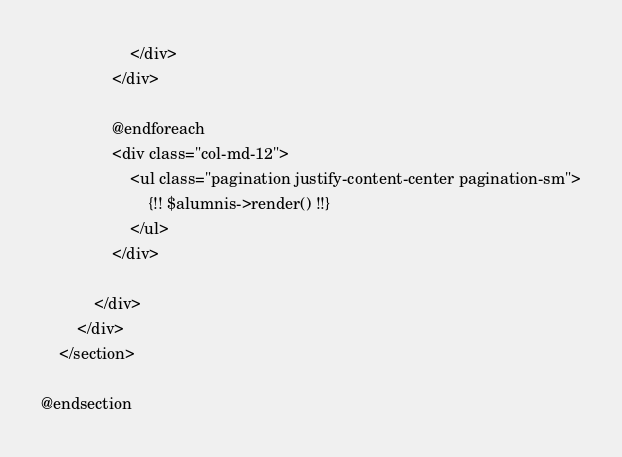<code> <loc_0><loc_0><loc_500><loc_500><_PHP_>		            </div>
		        </div>

		        @endforeach
		       	<div class="col-md-12">
					<ul class="pagination justify-content-center pagination-sm">
	                    {!! $alumnis->render() !!}
	                </ul>
	            </div>

	        </div>
	    </div>
    </section>

@endsection</code> 